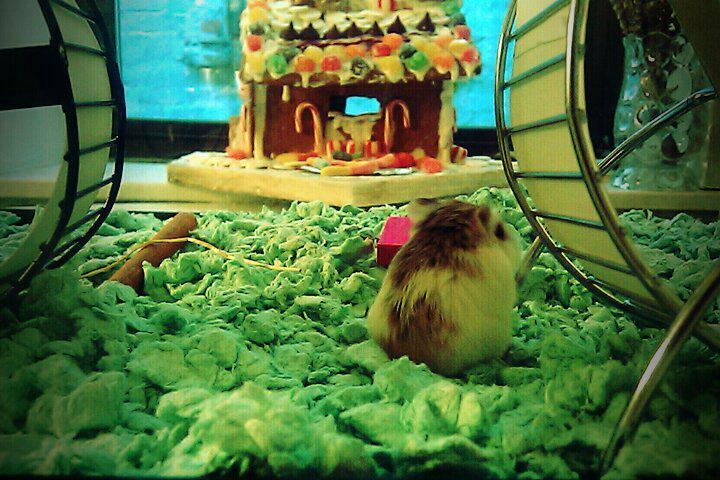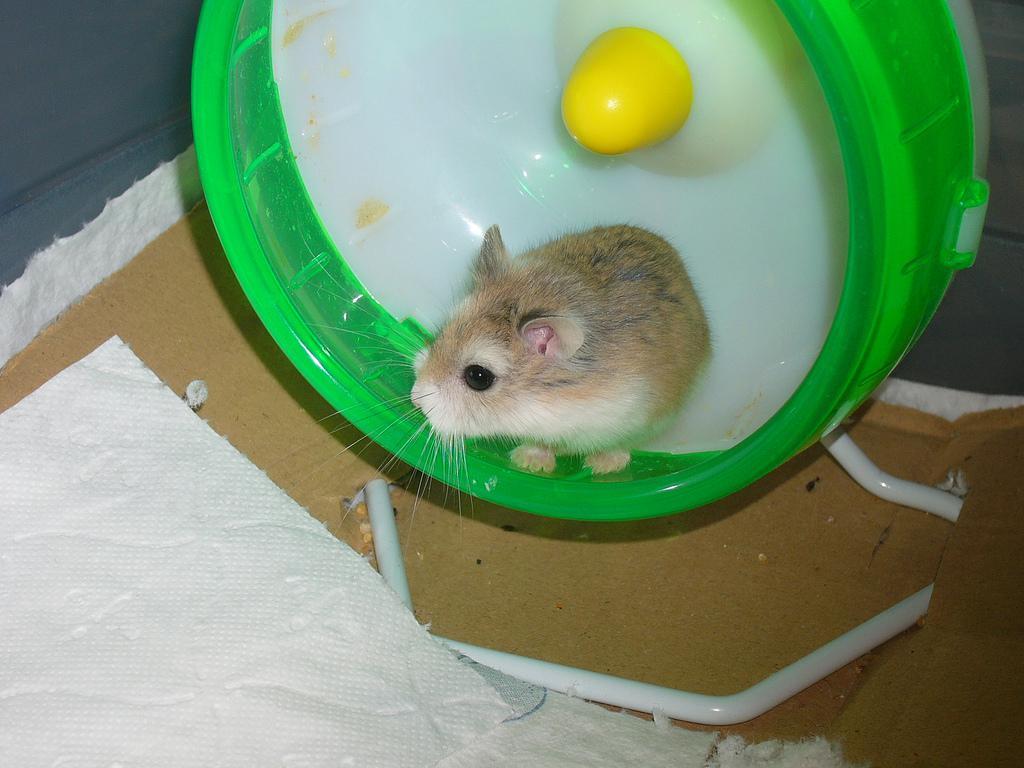The first image is the image on the left, the second image is the image on the right. Evaluate the accuracy of this statement regarding the images: "Each image shows a hamster in a wheel, and one image shows three hamsters in a wheel with non-mesh green sides.". Is it true? Answer yes or no. No. The first image is the image on the left, the second image is the image on the right. Examine the images to the left and right. Is the description "In one of the images, three hamsters are huddled together in a small space." accurate? Answer yes or no. No. 